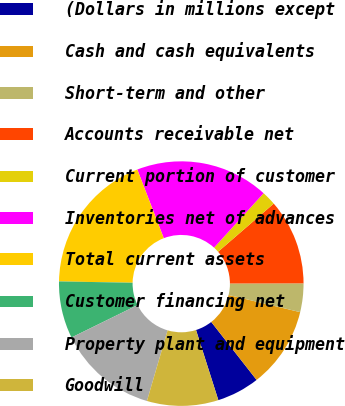<chart> <loc_0><loc_0><loc_500><loc_500><pie_chart><fcel>(Dollars in millions except<fcel>Cash and cash equivalents<fcel>Short-term and other<fcel>Accounts receivable net<fcel>Current portion of customer<fcel>Inventories net of advances<fcel>Total current assets<fcel>Customer financing net<fcel>Property plant and equipment<fcel>Goodwill<nl><fcel>5.66%<fcel>10.69%<fcel>3.78%<fcel>11.32%<fcel>1.89%<fcel>17.61%<fcel>18.86%<fcel>7.55%<fcel>13.21%<fcel>9.43%<nl></chart> 